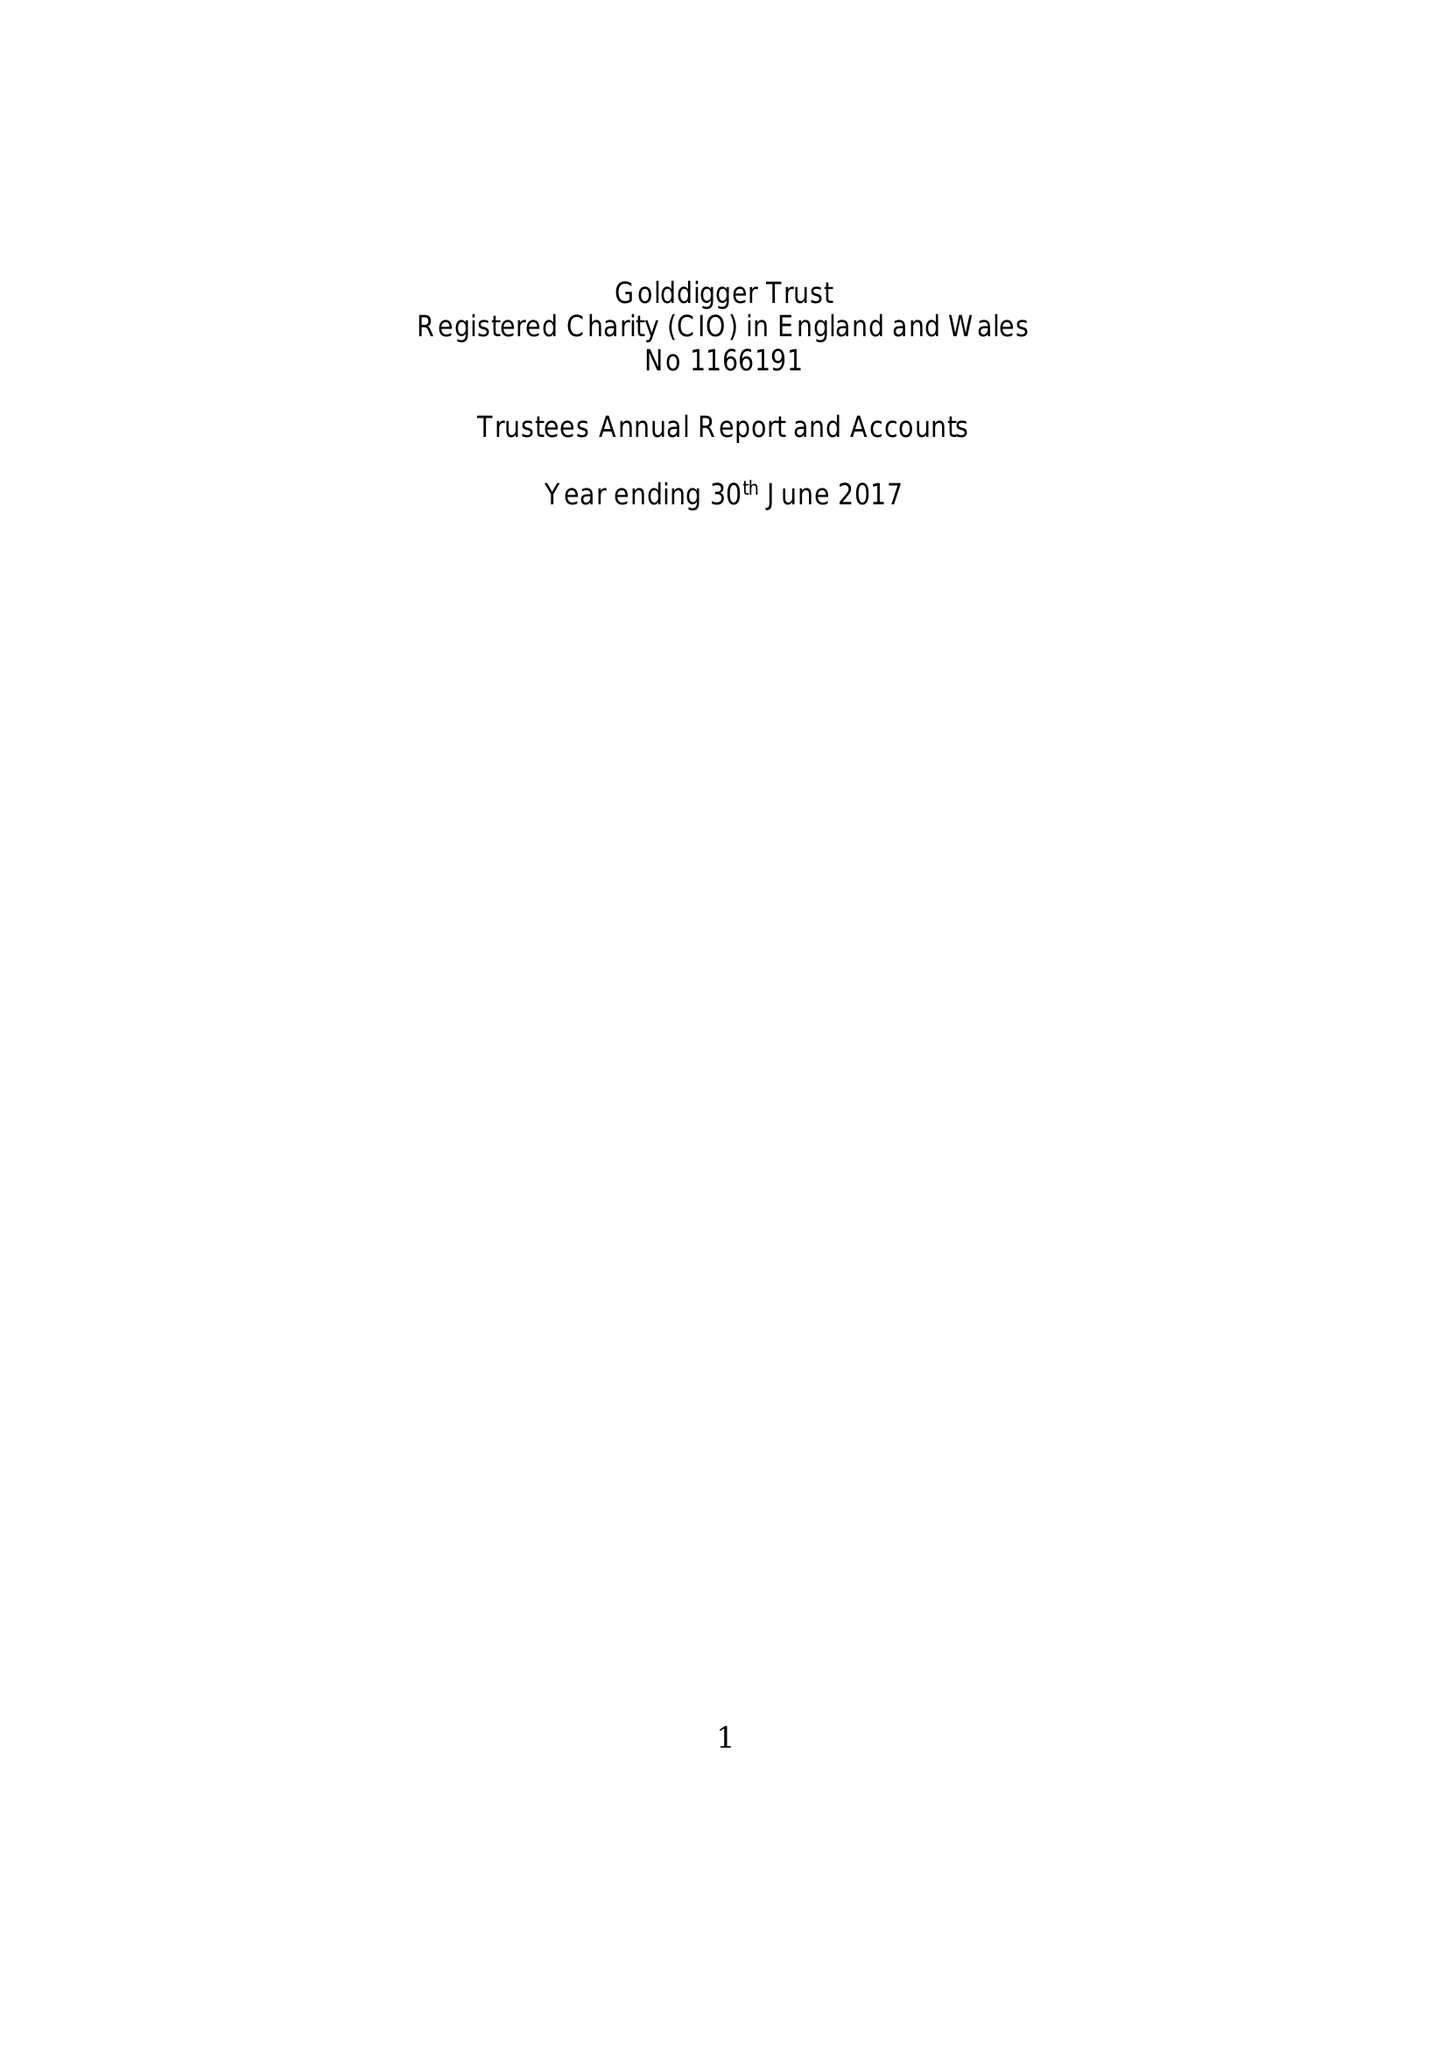What is the value for the spending_annually_in_british_pounds?
Answer the question using a single word or phrase. 134578.00 